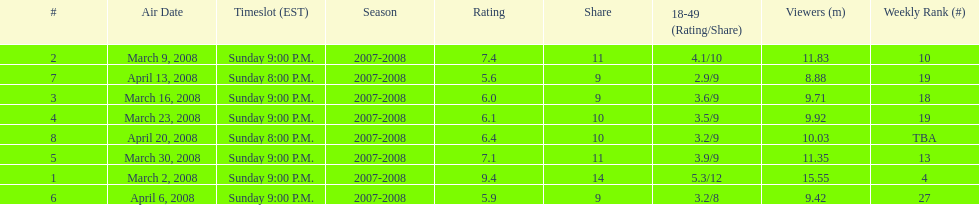Which show had the highest rating? 1. 